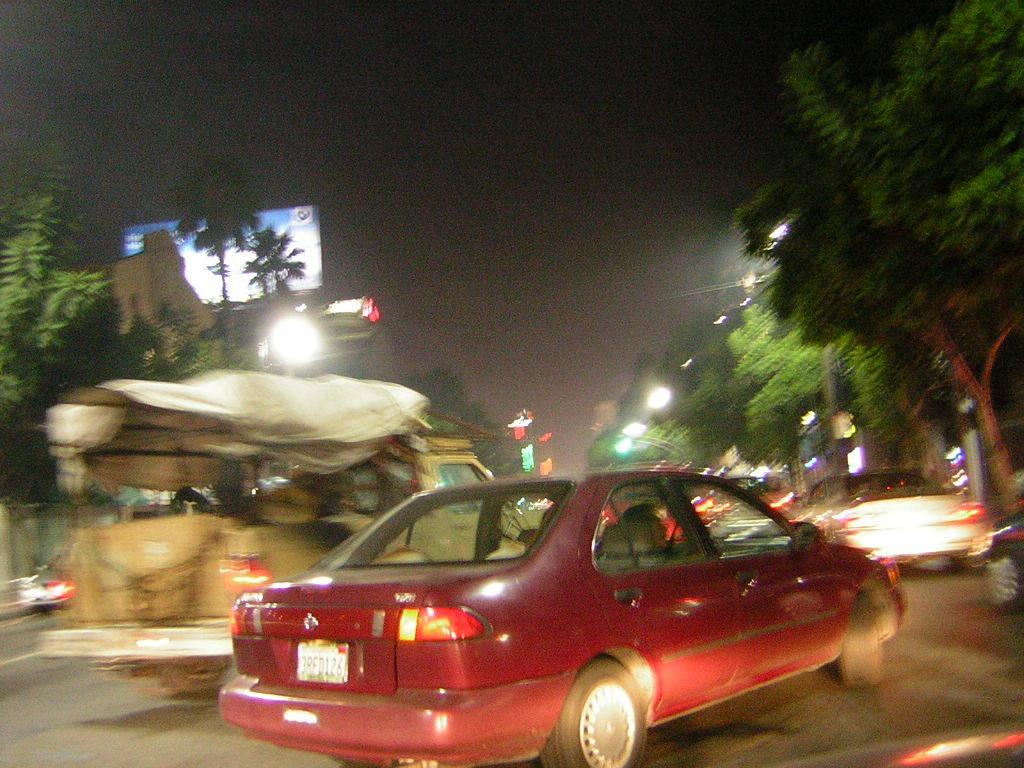What is the main subject of the image? There is a car on the road in the image. Are there any other vehicles visible in the image? Yes, there are other cars visible in the image. What type of natural elements can be seen in the image? There are trees in the image. What type of artificial elements can be seen in the image? There are lights in the image. What is visible in the background of the image? The sky is visible in the image. What type of potato is being used as a face mask in the image? There is no potato or face mask present in the image. Is there a jail visible in the image? No, there is no jail present in the image. 